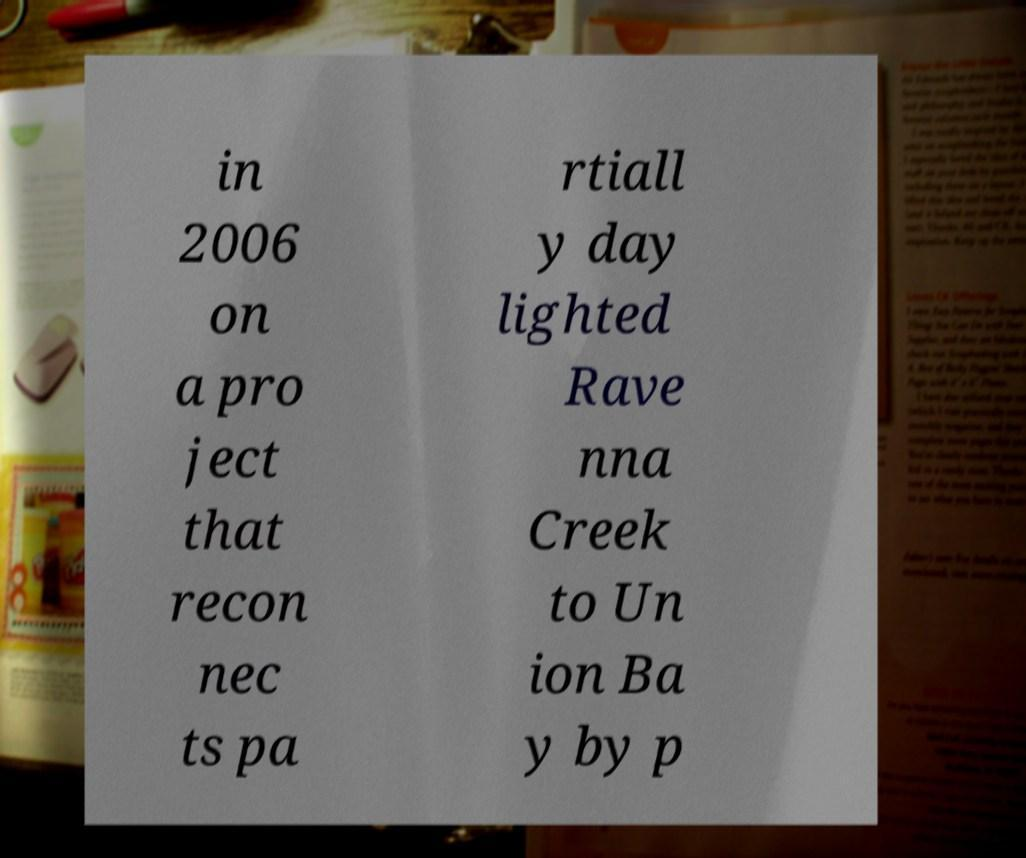For documentation purposes, I need the text within this image transcribed. Could you provide that? in 2006 on a pro ject that recon nec ts pa rtiall y day lighted Rave nna Creek to Un ion Ba y by p 